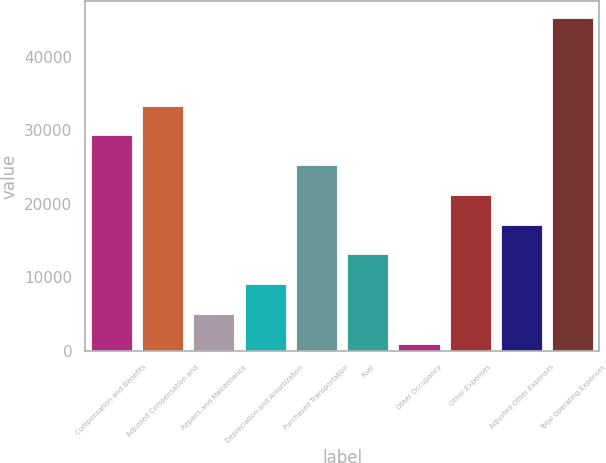Convert chart to OTSL. <chart><loc_0><loc_0><loc_500><loc_500><bar_chart><fcel>Compensation and Benefits<fcel>Adjusted Compensation and<fcel>Repairs and Maintenance<fcel>Depreciation and Amortization<fcel>Purchased Transportation<fcel>Fuel<fcel>Other Occupancy<fcel>Other Expenses<fcel>Adjusted Other Expenses<fcel>Total Operating Expenses<nl><fcel>29342.7<fcel>33393.8<fcel>5036.1<fcel>9087.2<fcel>25291.6<fcel>13138.3<fcel>985<fcel>21240.5<fcel>17189.4<fcel>45366.1<nl></chart> 